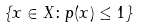<formula> <loc_0><loc_0><loc_500><loc_500>\{ x \in X \colon p ( x ) \leq 1 \}</formula> 